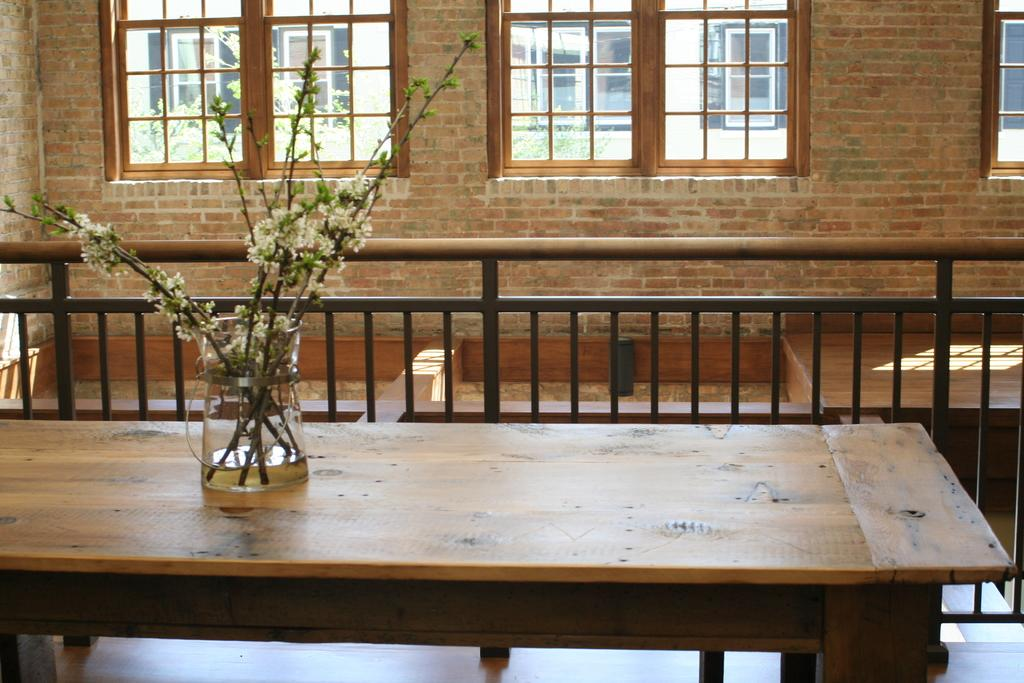What is the main piece of furniture in the image? There is a table in the image. What is placed on the table? There is a flower vase on the table. What can be seen in the background of the image? There is a railing and windows visible in the background of the image. How are the windows attached to the wall? The windows are attached to a wall. What type of fog can be seen outside the windows in the image? There is no fog visible outside the windows in the image. 